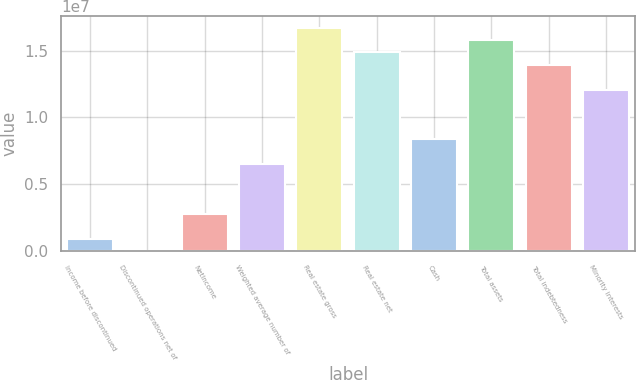<chart> <loc_0><loc_0><loc_500><loc_500><bar_chart><fcel>Income before discontinued<fcel>Discontinued operations net of<fcel>NetIncome<fcel>Weighted average number of<fcel>Real estate gross<fcel>Real estate net<fcel>Cash<fcel>Total assets<fcel>Total indebtedness<fcel>Minority interests<nl><fcel>929123<fcel>0.26<fcel>2.78737e+06<fcel>6.50386e+06<fcel>1.67242e+07<fcel>1.4866e+07<fcel>8.3621e+06<fcel>1.57951e+07<fcel>1.39368e+07<fcel>1.20786e+07<nl></chart> 